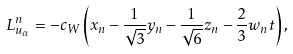<formula> <loc_0><loc_0><loc_500><loc_500>L _ { u _ { \alpha } } ^ { n } = - c _ { W } \left ( x _ { n } - \frac { 1 } { \sqrt { 3 } } y _ { n } - \frac { 1 } { \sqrt { 6 } } z _ { n } - \frac { 2 } { 3 } w _ { n } t \right ) ,</formula> 